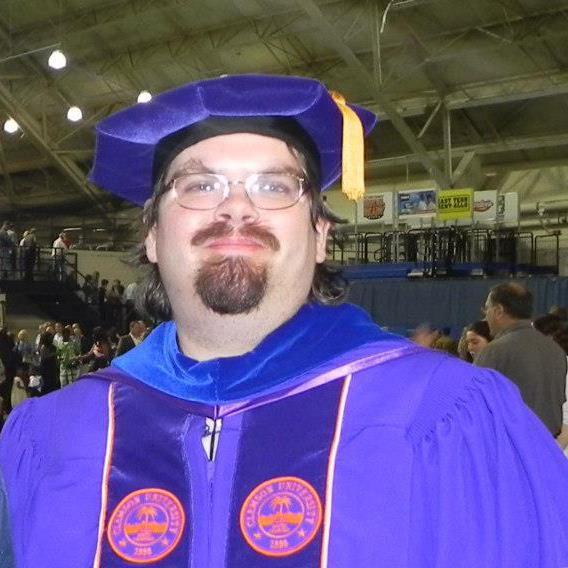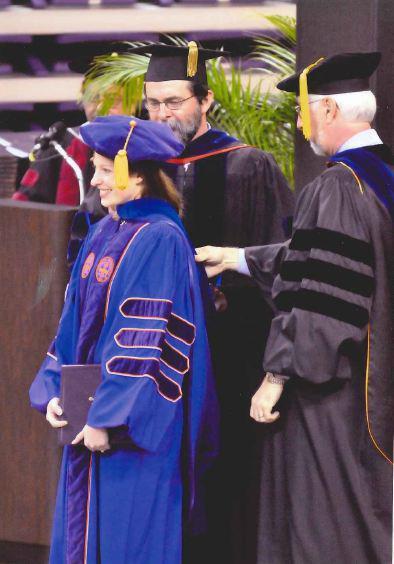The first image is the image on the left, the second image is the image on the right. Analyze the images presented: Is the assertion "Two people pose together outside wearing graduation attire in one of the images." valid? Answer yes or no. No. The first image is the image on the left, the second image is the image on the right. Examine the images to the left and right. Is the description "The left image shows a round-faced man with mustache and beard wearing a graduation robe and gold-tasseled cap, and the right image shows people in different colored robes with stripes on the sleeves." accurate? Answer yes or no. Yes. 